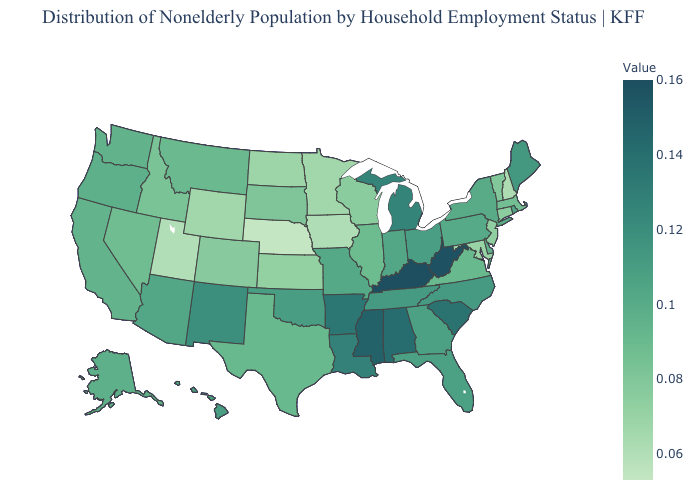Which states hav the highest value in the West?
Quick response, please. New Mexico. Among the states that border Florida , does Georgia have the lowest value?
Write a very short answer. Yes. Which states hav the highest value in the South?
Keep it brief. Kentucky. Does the map have missing data?
Be succinct. No. Among the states that border Utah , which have the highest value?
Write a very short answer. New Mexico. Which states have the lowest value in the MidWest?
Answer briefly. Nebraska. Is the legend a continuous bar?
Be succinct. Yes. 